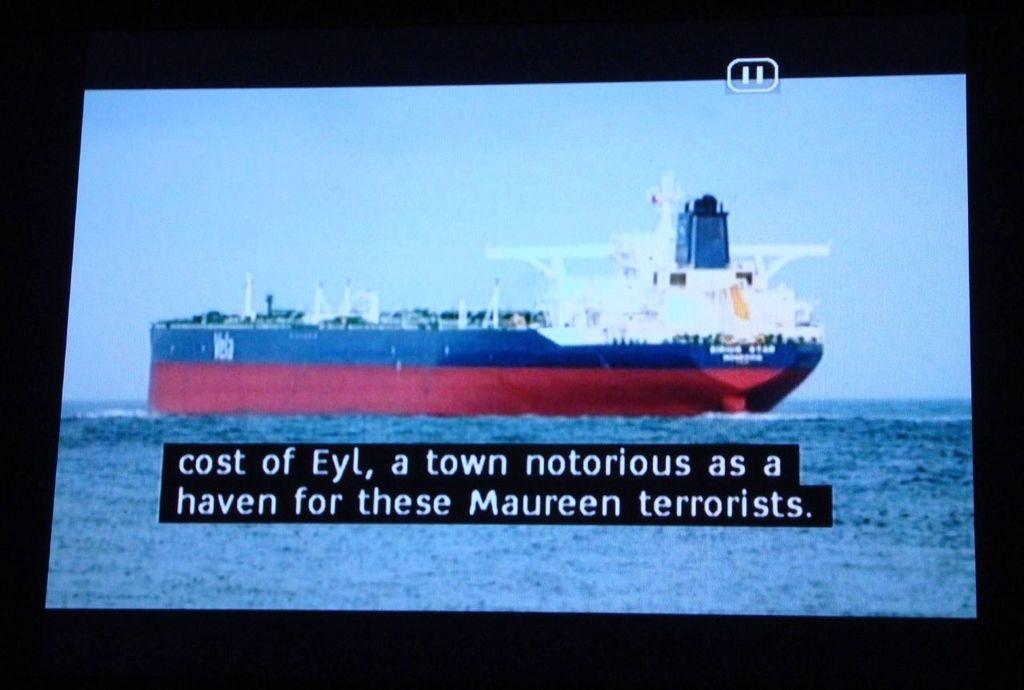What kind of terrorists are mentioned?
Your response must be concise. Maureen. 